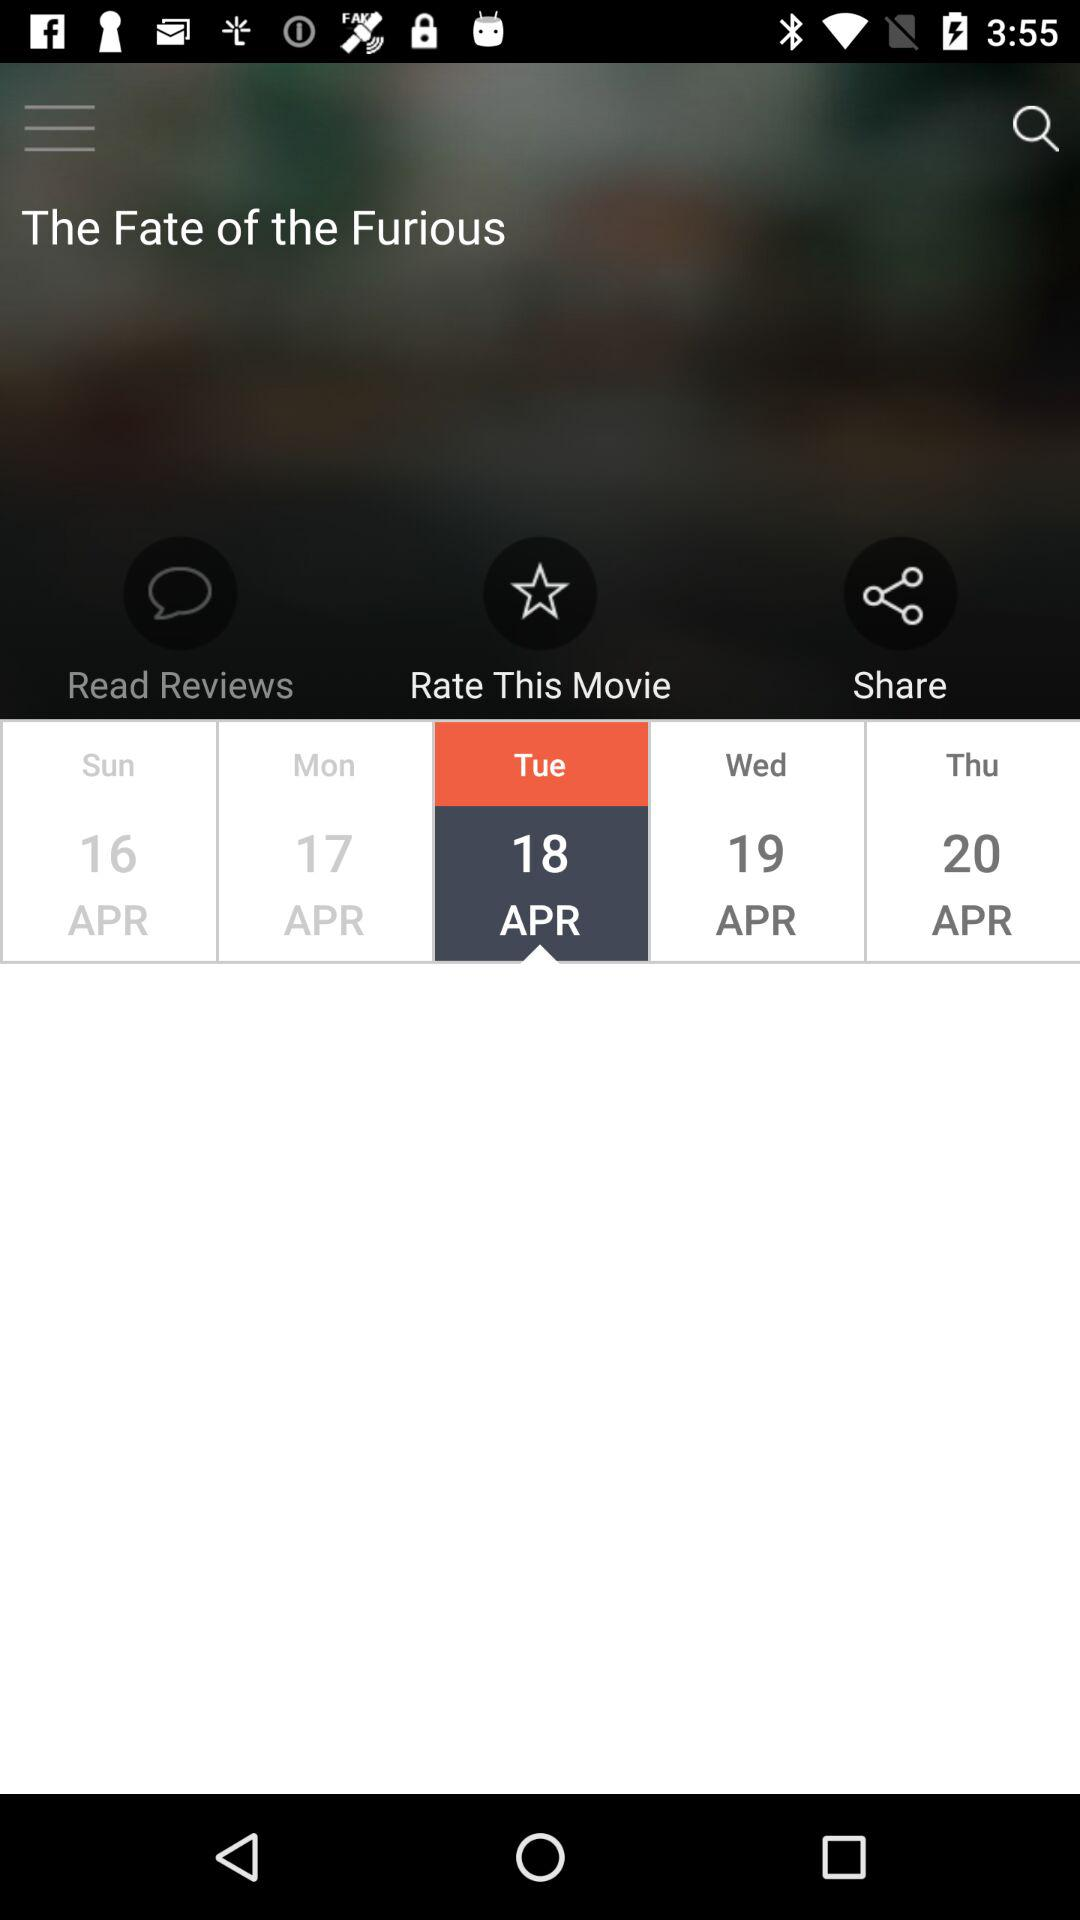Which date is on Thursday? The date is April 20. 